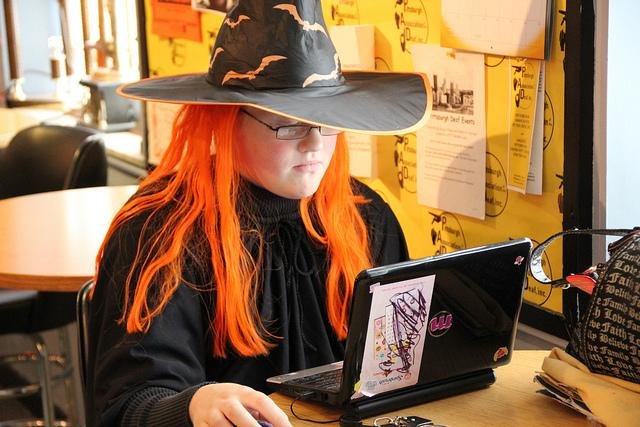What hat does the woman have on?

Choices:
A) wool
B) baseball cap
C) fedora
D) witch hat witch hat 